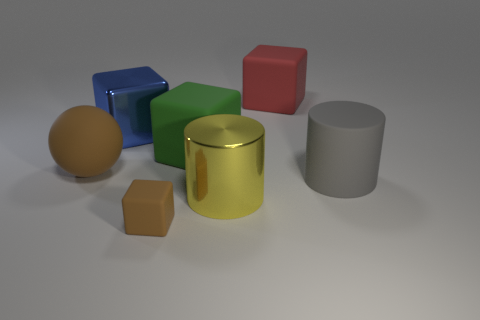Is there a rubber object of the same color as the small rubber block?
Offer a very short reply. Yes. There is a large matte object that is to the left of the green cube; is it the same color as the tiny thing?
Provide a short and direct response. Yes. What is the size of the matte thing that is both on the left side of the large green rubber cube and on the right side of the blue cube?
Offer a terse response. Small. Does the rubber cylinder have the same color as the tiny rubber block left of the large yellow object?
Your response must be concise. No. There is a metal thing that is in front of the matte object left of the metal thing that is to the left of the yellow shiny object; what is its color?
Make the answer very short. Yellow. There is another thing that is the same shape as the gray object; what color is it?
Offer a terse response. Yellow. Is the number of cylinders that are left of the big metal cube the same as the number of tiny purple things?
Offer a very short reply. Yes. How many blocks are large brown rubber things or rubber objects?
Give a very brief answer. 3. There is a tiny thing that is made of the same material as the large green cube; what color is it?
Provide a short and direct response. Brown. Does the tiny thing have the same material as the thing right of the large red rubber object?
Provide a short and direct response. Yes. 